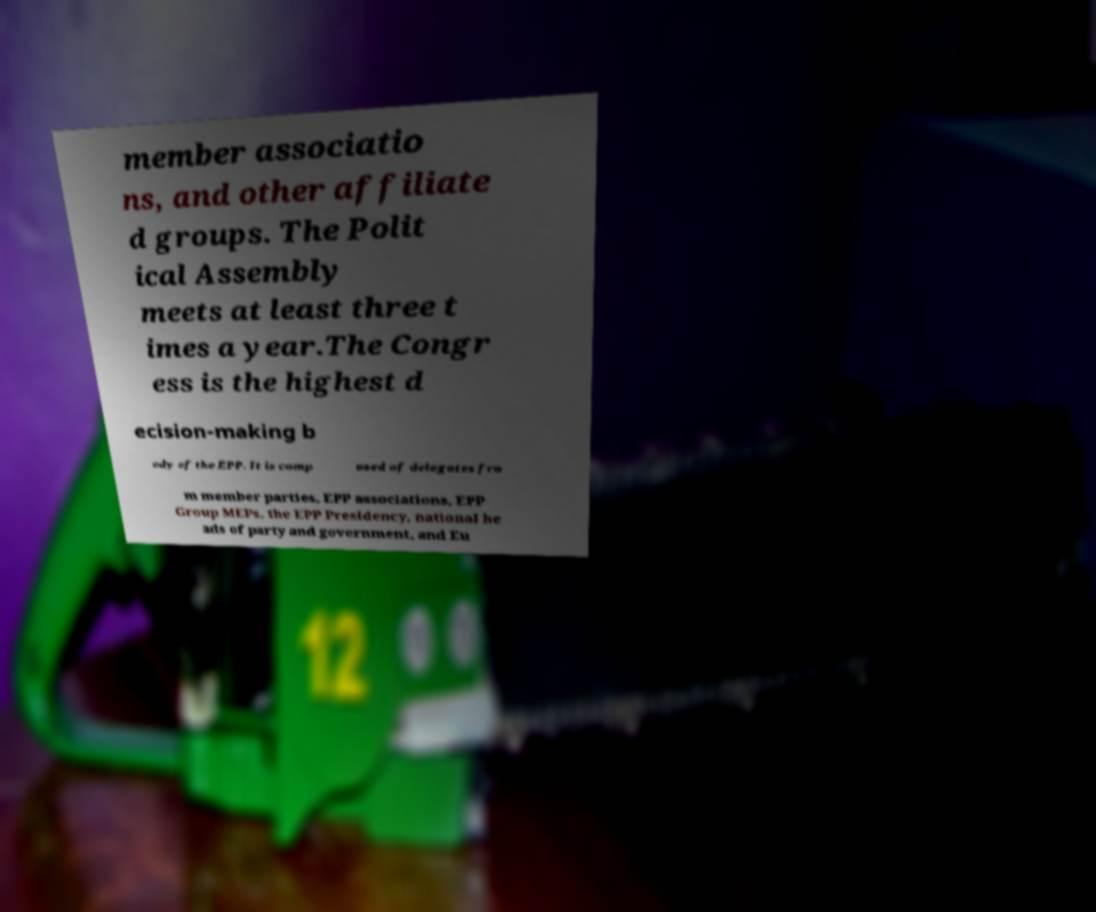Can you accurately transcribe the text from the provided image for me? member associatio ns, and other affiliate d groups. The Polit ical Assembly meets at least three t imes a year.The Congr ess is the highest d ecision-making b ody of the EPP. It is comp osed of delegates fro m member parties, EPP associations, EPP Group MEPs, the EPP Presidency, national he ads of party and government, and Eu 